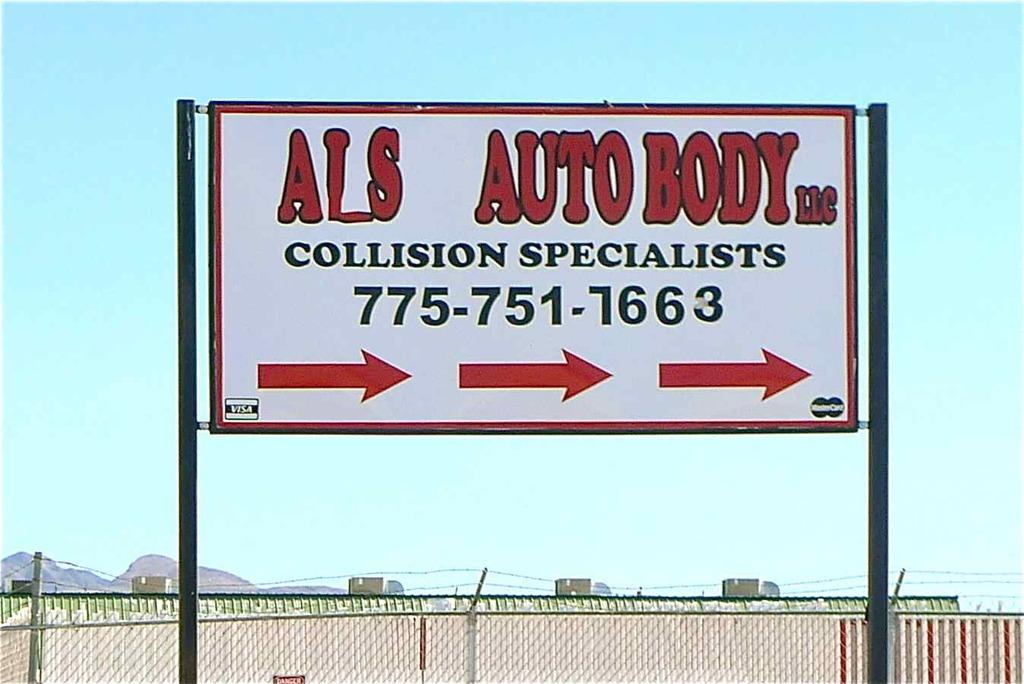Provide a one-sentence caption for the provided image. Sign with Als Auto body collision specialist and a phone number. 